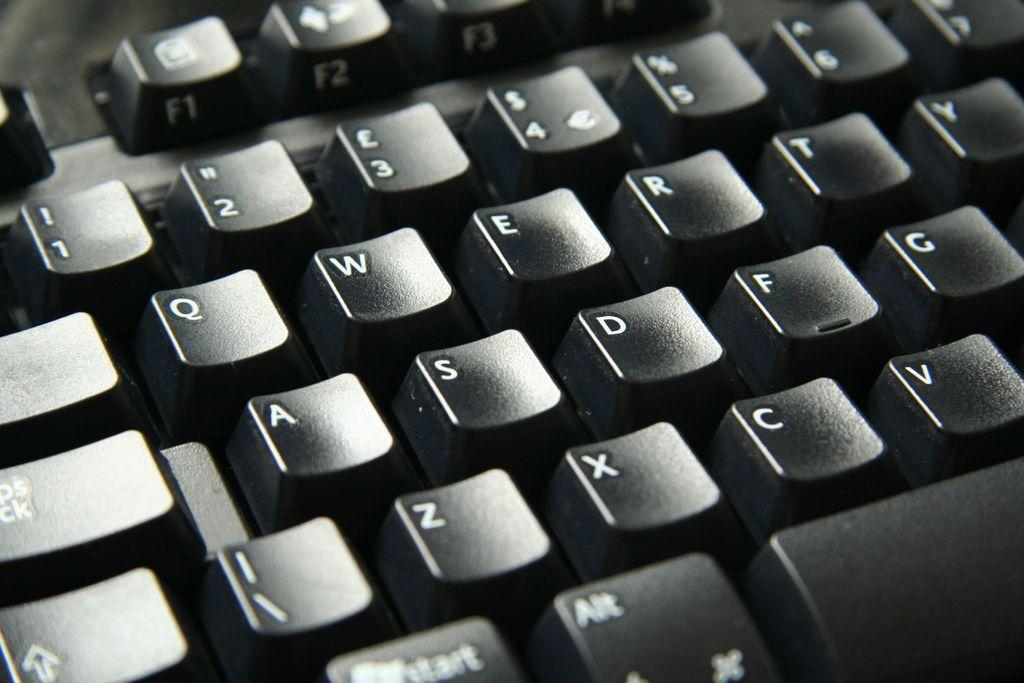Provide a one-sentence caption for the provided image. A black keyboard with the caps lock key and qwerty showing. 